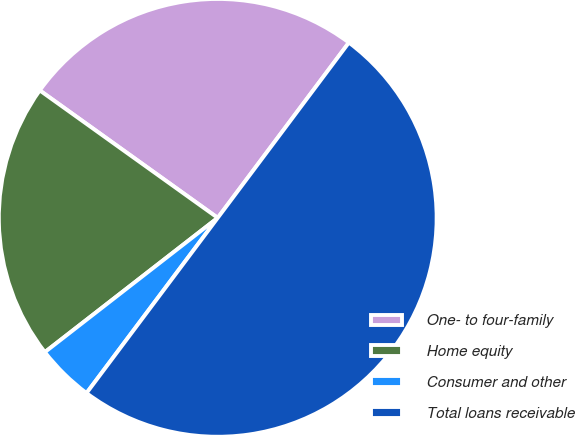Convert chart. <chart><loc_0><loc_0><loc_500><loc_500><pie_chart><fcel>One- to four-family<fcel>Home equity<fcel>Consumer and other<fcel>Total loans receivable<nl><fcel>25.33%<fcel>20.4%<fcel>4.26%<fcel>50.0%<nl></chart> 